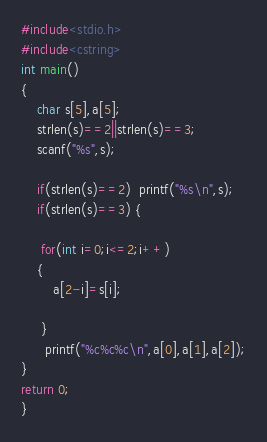Convert code to text. <code><loc_0><loc_0><loc_500><loc_500><_C++_>#include<stdio.h>
#include<cstring>
int main()
{
	char s[5],a[5];
	strlen(s)==2||strlen(s)==3;
	scanf("%s",s);

	if(strlen(s)==2)  printf("%s\n",s);
	if(strlen(s)==3) {
	
	 for(int i=0;i<=2;i++)
	{
		a[2-i]=s[i];
	 
	 }
	  printf("%c%c%c\n",a[0],a[1],a[2]);
}
return 0;
}
</code> 